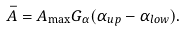<formula> <loc_0><loc_0><loc_500><loc_500>\bar { A } = A _ { \max } G _ { \alpha } ( \alpha _ { u p } - \alpha _ { l o w } ) .</formula> 